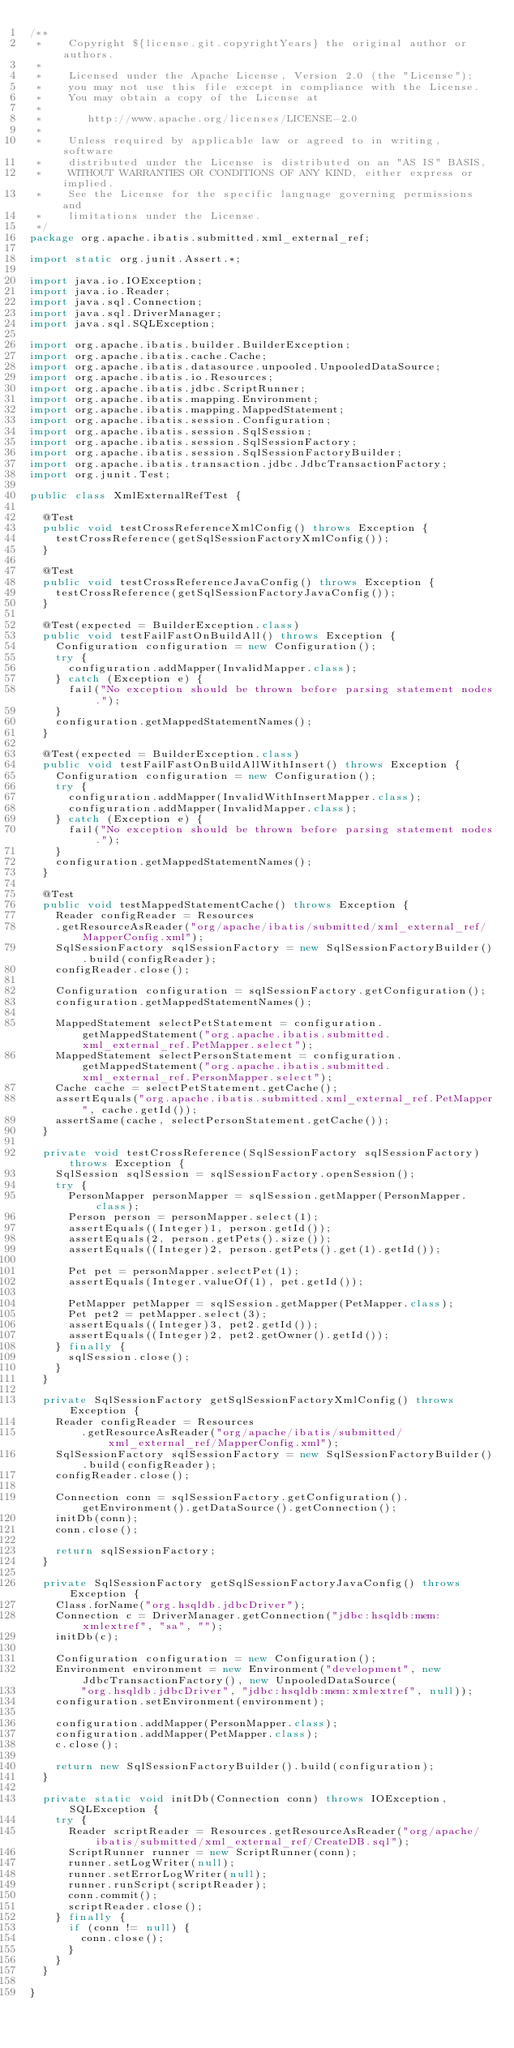<code> <loc_0><loc_0><loc_500><loc_500><_Java_>/**
 *    Copyright ${license.git.copyrightYears} the original author or authors.
 *
 *    Licensed under the Apache License, Version 2.0 (the "License");
 *    you may not use this file except in compliance with the License.
 *    You may obtain a copy of the License at
 *
 *       http://www.apache.org/licenses/LICENSE-2.0
 *
 *    Unless required by applicable law or agreed to in writing, software
 *    distributed under the License is distributed on an "AS IS" BASIS,
 *    WITHOUT WARRANTIES OR CONDITIONS OF ANY KIND, either express or implied.
 *    See the License for the specific language governing permissions and
 *    limitations under the License.
 */
package org.apache.ibatis.submitted.xml_external_ref;

import static org.junit.Assert.*;

import java.io.IOException;
import java.io.Reader;
import java.sql.Connection;
import java.sql.DriverManager;
import java.sql.SQLException;

import org.apache.ibatis.builder.BuilderException;
import org.apache.ibatis.cache.Cache;
import org.apache.ibatis.datasource.unpooled.UnpooledDataSource;
import org.apache.ibatis.io.Resources;
import org.apache.ibatis.jdbc.ScriptRunner;
import org.apache.ibatis.mapping.Environment;
import org.apache.ibatis.mapping.MappedStatement;
import org.apache.ibatis.session.Configuration;
import org.apache.ibatis.session.SqlSession;
import org.apache.ibatis.session.SqlSessionFactory;
import org.apache.ibatis.session.SqlSessionFactoryBuilder;
import org.apache.ibatis.transaction.jdbc.JdbcTransactionFactory;
import org.junit.Test;

public class XmlExternalRefTest {

  @Test
  public void testCrossReferenceXmlConfig() throws Exception {
    testCrossReference(getSqlSessionFactoryXmlConfig());
  }

  @Test
  public void testCrossReferenceJavaConfig() throws Exception {
    testCrossReference(getSqlSessionFactoryJavaConfig());
  }

  @Test(expected = BuilderException.class)
  public void testFailFastOnBuildAll() throws Exception {
    Configuration configuration = new Configuration();
    try {
      configuration.addMapper(InvalidMapper.class);
    } catch (Exception e) {
      fail("No exception should be thrown before parsing statement nodes.");
    }
    configuration.getMappedStatementNames();
  }
  
  @Test(expected = BuilderException.class)
  public void testFailFastOnBuildAllWithInsert() throws Exception {
    Configuration configuration = new Configuration();
    try {
      configuration.addMapper(InvalidWithInsertMapper.class);
      configuration.addMapper(InvalidMapper.class);
    } catch (Exception e) {
      fail("No exception should be thrown before parsing statement nodes.");
    }
    configuration.getMappedStatementNames();
  }

  @Test
  public void testMappedStatementCache() throws Exception {
    Reader configReader = Resources
    .getResourceAsReader("org/apache/ibatis/submitted/xml_external_ref/MapperConfig.xml");
    SqlSessionFactory sqlSessionFactory = new SqlSessionFactoryBuilder().build(configReader);
    configReader.close();

    Configuration configuration = sqlSessionFactory.getConfiguration();
    configuration.getMappedStatementNames();

    MappedStatement selectPetStatement = configuration.getMappedStatement("org.apache.ibatis.submitted.xml_external_ref.PetMapper.select");
    MappedStatement selectPersonStatement = configuration.getMappedStatement("org.apache.ibatis.submitted.xml_external_ref.PersonMapper.select");
    Cache cache = selectPetStatement.getCache();
    assertEquals("org.apache.ibatis.submitted.xml_external_ref.PetMapper", cache.getId());
    assertSame(cache, selectPersonStatement.getCache());
  }

  private void testCrossReference(SqlSessionFactory sqlSessionFactory) throws Exception {
    SqlSession sqlSession = sqlSessionFactory.openSession();
    try {
      PersonMapper personMapper = sqlSession.getMapper(PersonMapper.class);
      Person person = personMapper.select(1);
      assertEquals((Integer)1, person.getId());
      assertEquals(2, person.getPets().size());
      assertEquals((Integer)2, person.getPets().get(1).getId());

      Pet pet = personMapper.selectPet(1);
      assertEquals(Integer.valueOf(1), pet.getId());

      PetMapper petMapper = sqlSession.getMapper(PetMapper.class);
      Pet pet2 = petMapper.select(3);
      assertEquals((Integer)3, pet2.getId());
      assertEquals((Integer)2, pet2.getOwner().getId());
    } finally {
      sqlSession.close();
    }
  }

  private SqlSessionFactory getSqlSessionFactoryXmlConfig() throws Exception {
    Reader configReader = Resources
        .getResourceAsReader("org/apache/ibatis/submitted/xml_external_ref/MapperConfig.xml");
    SqlSessionFactory sqlSessionFactory = new SqlSessionFactoryBuilder().build(configReader);
    configReader.close();

    Connection conn = sqlSessionFactory.getConfiguration().getEnvironment().getDataSource().getConnection();
    initDb(conn);
    conn.close();

    return sqlSessionFactory;
  }

  private SqlSessionFactory getSqlSessionFactoryJavaConfig() throws Exception {
    Class.forName("org.hsqldb.jdbcDriver");
    Connection c = DriverManager.getConnection("jdbc:hsqldb:mem:xmlextref", "sa", "");
    initDb(c);

    Configuration configuration = new Configuration();
    Environment environment = new Environment("development", new JdbcTransactionFactory(), new UnpooledDataSource(
        "org.hsqldb.jdbcDriver", "jdbc:hsqldb:mem:xmlextref", null));
    configuration.setEnvironment(environment);

    configuration.addMapper(PersonMapper.class);
    configuration.addMapper(PetMapper.class);
    c.close();

    return new SqlSessionFactoryBuilder().build(configuration);
  }

  private static void initDb(Connection conn) throws IOException, SQLException {
    try {
      Reader scriptReader = Resources.getResourceAsReader("org/apache/ibatis/submitted/xml_external_ref/CreateDB.sql");
      ScriptRunner runner = new ScriptRunner(conn);
      runner.setLogWriter(null);
      runner.setErrorLogWriter(null);
      runner.runScript(scriptReader);
      conn.commit();
      scriptReader.close();
    } finally {
      if (conn != null) {
        conn.close();
      }
    }
  }

}
</code> 